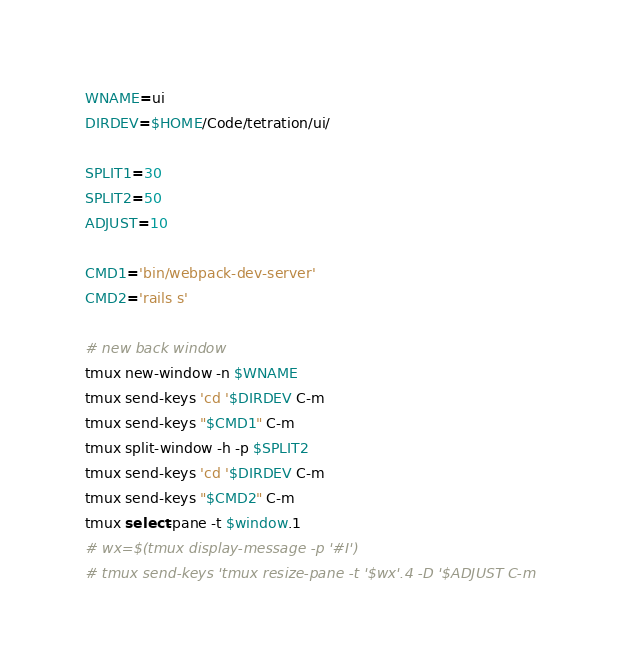<code> <loc_0><loc_0><loc_500><loc_500><_Bash_>WNAME=ui
DIRDEV=$HOME/Code/tetration/ui/

SPLIT1=30
SPLIT2=50
ADJUST=10

CMD1='bin/webpack-dev-server'
CMD2='rails s'

# new back window
tmux new-window -n $WNAME
tmux send-keys 'cd '$DIRDEV C-m
tmux send-keys "$CMD1" C-m
tmux split-window -h -p $SPLIT2
tmux send-keys 'cd '$DIRDEV C-m
tmux send-keys "$CMD2" C-m
tmux select-pane -t $window.1
# wx=$(tmux display-message -p '#I')
# tmux send-keys 'tmux resize-pane -t '$wx'.4 -D '$ADJUST C-m
</code> 